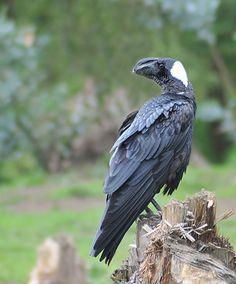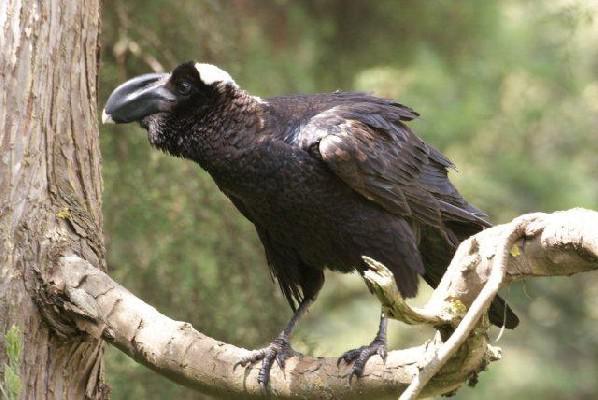The first image is the image on the left, the second image is the image on the right. For the images shown, is this caption "Large groups of vultures are gathered on walls of wood or brick in one of the images." true? Answer yes or no. No. The first image is the image on the left, the second image is the image on the right. For the images displayed, is the sentence "There are at most three ravens standing on a branch" factually correct? Answer yes or no. Yes. 